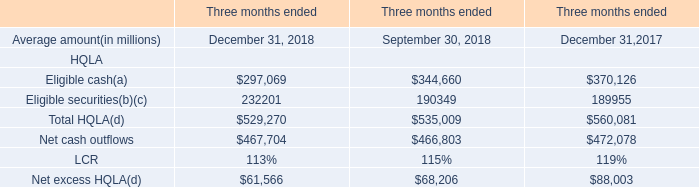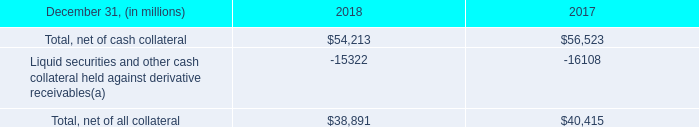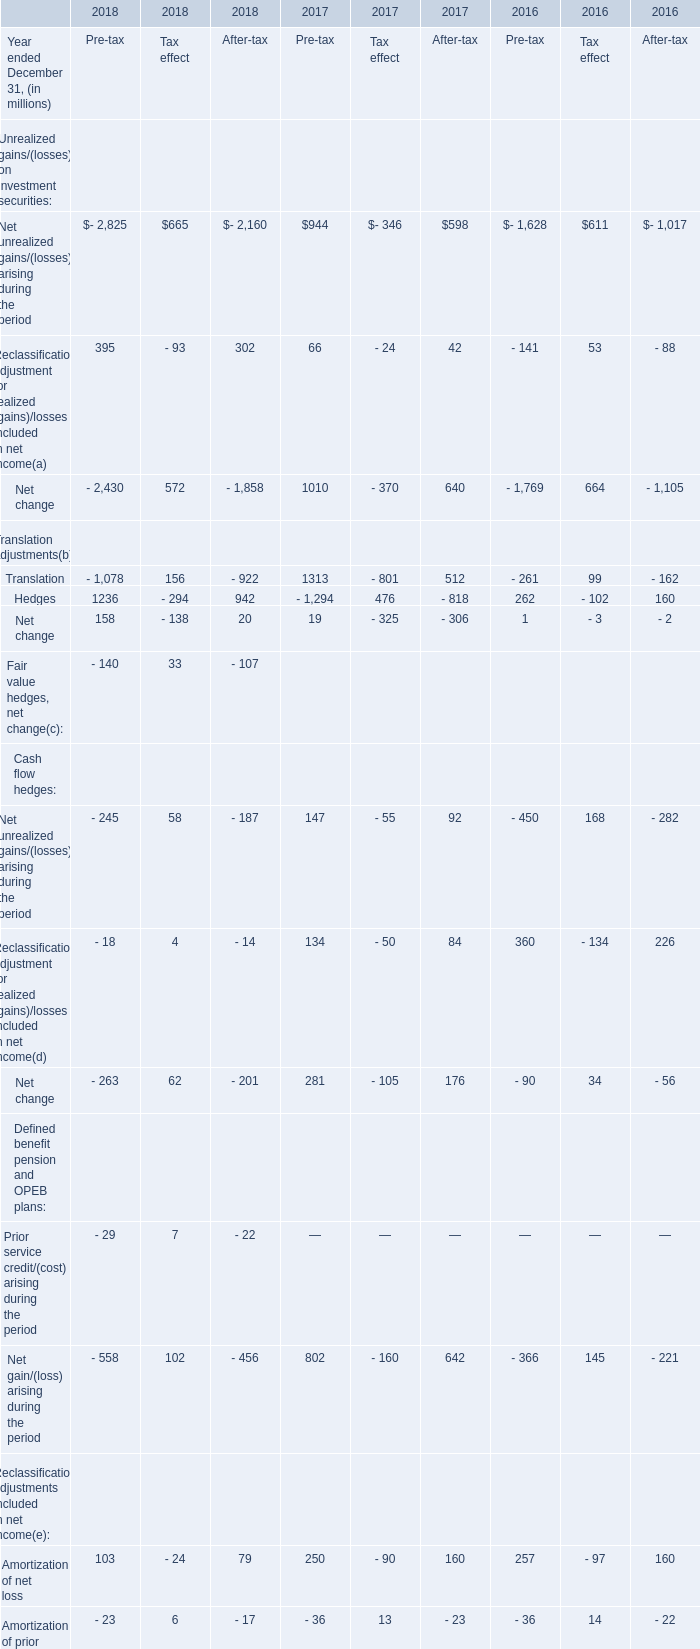what was the ratio of the fair value of derivative receivables reported on the consolidated balance sheets at december 31 , 2018 and 2017 . 
Computations: (54.2 / 56.5)
Answer: 0.95929. 